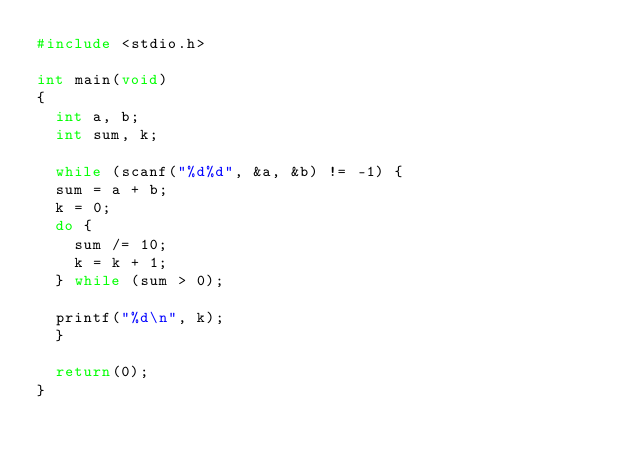Convert code to text. <code><loc_0><loc_0><loc_500><loc_500><_C_>#include <stdio.h>

int main(void)
{
  int a, b;
  int sum, k;

  while (scanf("%d%d", &a, &b) != -1) {
  sum = a + b;
  k = 0;
  do {
    sum /= 10;
    k = k + 1;
  } while (sum > 0);

  printf("%d\n", k);
  }

  return(0);
}</code> 